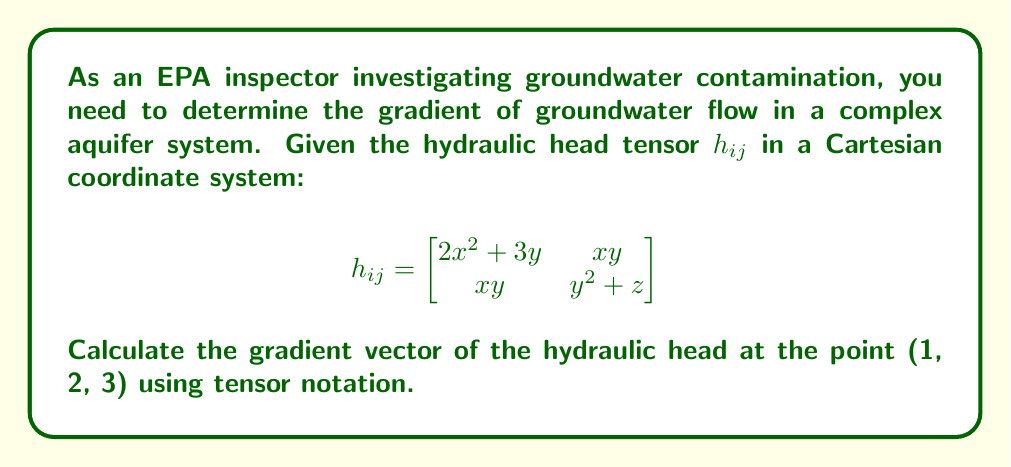Solve this math problem. To solve this problem, we'll follow these steps:

1) The gradient of a scalar field in tensor notation is given by:

   $$\nabla h = \frac{\partial h}{\partial x_i} = \frac{\partial h}{\partial x}\hat{i} + \frac{\partial h}{\partial y}\hat{j} + \frac{\partial h}{\partial z}\hat{k}$$

2) In our case, we need to calculate $\frac{\partial h}{\partial x_i}$ from the given tensor $h_{ij}$. We'll use the trace of the tensor:

   $$h = \text{tr}(h_{ij}) = (2x^2 + 3y) + (y^2 + z)$$

3) Now, let's calculate each component of the gradient:

   $$\frac{\partial h}{\partial x} = \frac{\partial}{\partial x}(2x^2 + 3y + y^2 + z) = 4x$$

   $$\frac{\partial h}{\partial y} = \frac{\partial}{\partial y}(2x^2 + 3y + y^2 + z) = 3 + 2y$$

   $$\frac{\partial h}{\partial z} = \frac{\partial}{\partial z}(2x^2 + 3y + y^2 + z) = 1$$

4) Substituting the point (1, 2, 3) into these expressions:

   $$\frac{\partial h}{\partial x}\bigg|_{(1,2,3)} = 4(1) = 4$$

   $$\frac{\partial h}{\partial y}\bigg|_{(1,2,3)} = 3 + 2(2) = 7$$

   $$\frac{\partial h}{\partial z}\bigg|_{(1,2,3)} = 1$$

5) Therefore, the gradient vector at (1, 2, 3) is:

   $$\nabla h = 4\hat{i} + 7\hat{j} + \hat{k}$$
Answer: $\nabla h = 4\hat{i} + 7\hat{j} + \hat{k}$ 